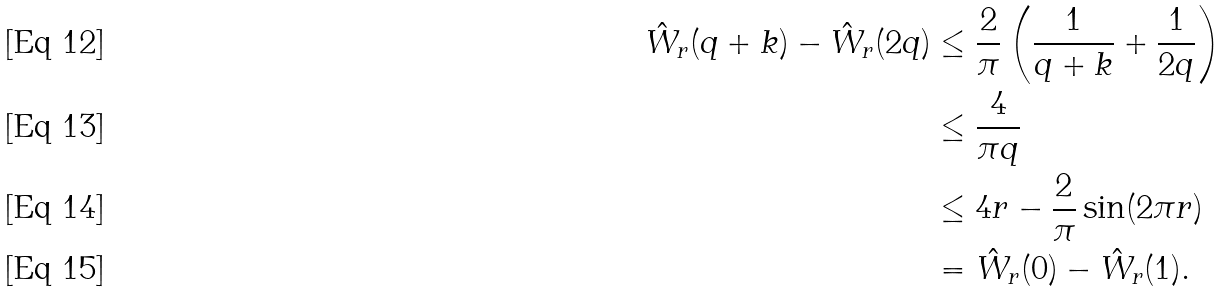Convert formula to latex. <formula><loc_0><loc_0><loc_500><loc_500>\hat { W } _ { r } ( q + k ) - \hat { W } _ { r } ( 2 q ) & \leq \frac { 2 } { \pi } \left ( \frac { 1 } { q + k } + \frac { 1 } { 2 q } \right ) \\ & \leq \frac { 4 } { \pi q } \\ & \leq 4 r - \frac { 2 } { \pi } \sin ( 2 \pi r ) \\ & = \hat { W } _ { r } ( 0 ) - \hat { W } _ { r } ( 1 ) .</formula> 